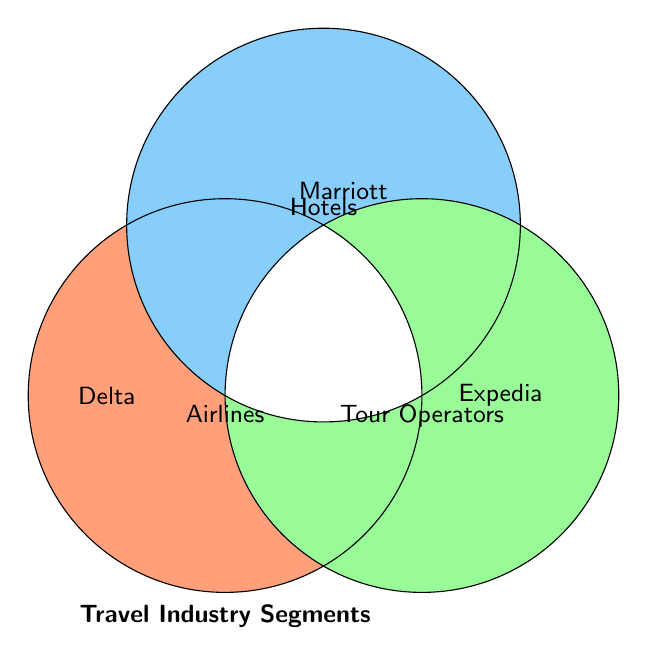What's the title of the Venn Diagram? The title of the Venn Diagram is located at the bottom center of the diagram and it reads "Travel Industry Segments".
Answer: Travel Industry Segments Which color represents the Airlines segment? The color representing the Airlines segment is seen on the left circle of the Venn Diagram. It has a peach-like color.
Answer: Peach-like color Name one company that belongs to the Hotels segment. The Venn Diagram shows "Marriott" in the upper circle representing the Hotels segment.
Answer: Marriott Are Expedia and Marriott in the same segment? The Venn Diagram places "Expedia" in the right circle for Tour Operators and "Marriott" in the upper circle for Hotels, indicating they are in different segments.
Answer: No How many segments are present in the Venn Diagram? The Venn Diagram has three overlapping circles representing three segments: Airlines, Hotels, and Tour Operators.
Answer: Three segments Which segment includes Delta? Delta is located within the left circle representing the Airlines segment.
Answer: Airlines Is there any overlap between the Airlines and Tour Operators segments shown? The Venn Diagram does not show any overlapping regions between the Airlines and Tour Operators circles, indicating no overlap.
Answer: No Combine the number of segments for Marriott and Expedia. Marriott belongs to the Hotels segment, and Expedia belongs to the Tour Operators segment. So, combining the segments gives Hotels + Tour Operators.
Answer: Hotels and Tour Operators Which segment does the top circle represent? The top circle in the Venn Diagram represents the Hotels segment.
Answer: Hotels What is the visual intersection of Airlines, Hotels, and Tour Operators? There are no companies placed in the intersection area where all three circles overlap, indicating no single company belongs to all three segments.
Answer: No intersection 